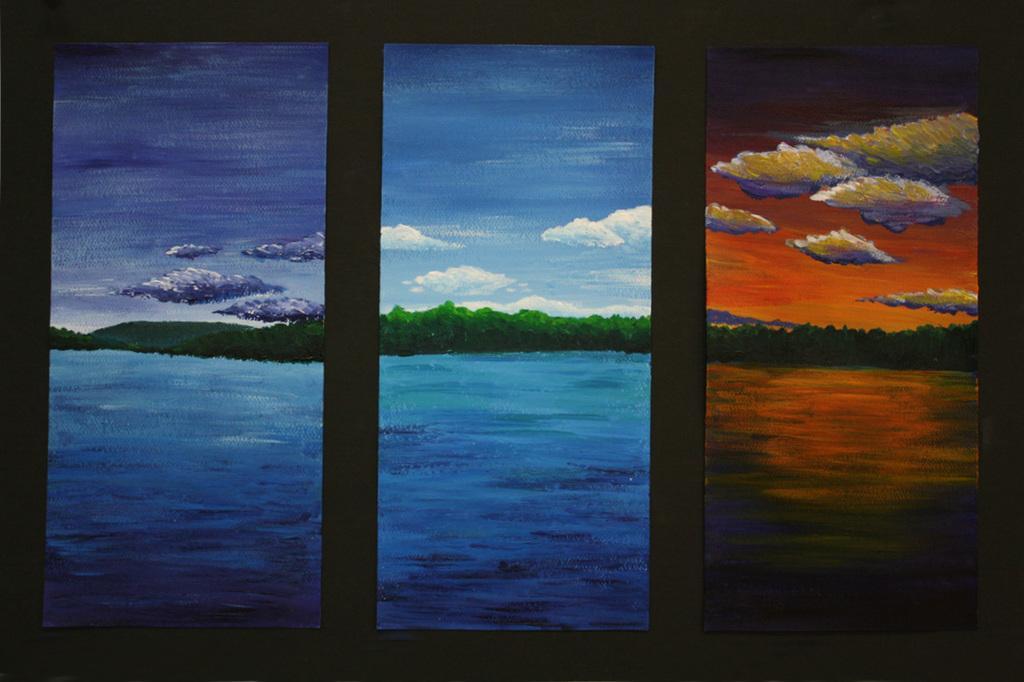How would you summarize this image in a sentence or two? In this image, we can see paintings on the wall and in all of these paintings, we can see trees, hills, clouds in the sky and there is water. 